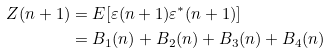<formula> <loc_0><loc_0><loc_500><loc_500>Z ( n + 1 ) & = E [ \varepsilon ( n + 1 ) \varepsilon ^ { * } ( n + 1 ) ] \\ & = B _ { 1 } ( n ) + B _ { 2 } ( n ) + B _ { 3 } ( n ) + B _ { 4 } ( n )</formula> 